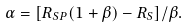Convert formula to latex. <formula><loc_0><loc_0><loc_500><loc_500>\alpha = [ R _ { S P } ( 1 + \beta ) - R _ { S } ] / \beta .</formula> 